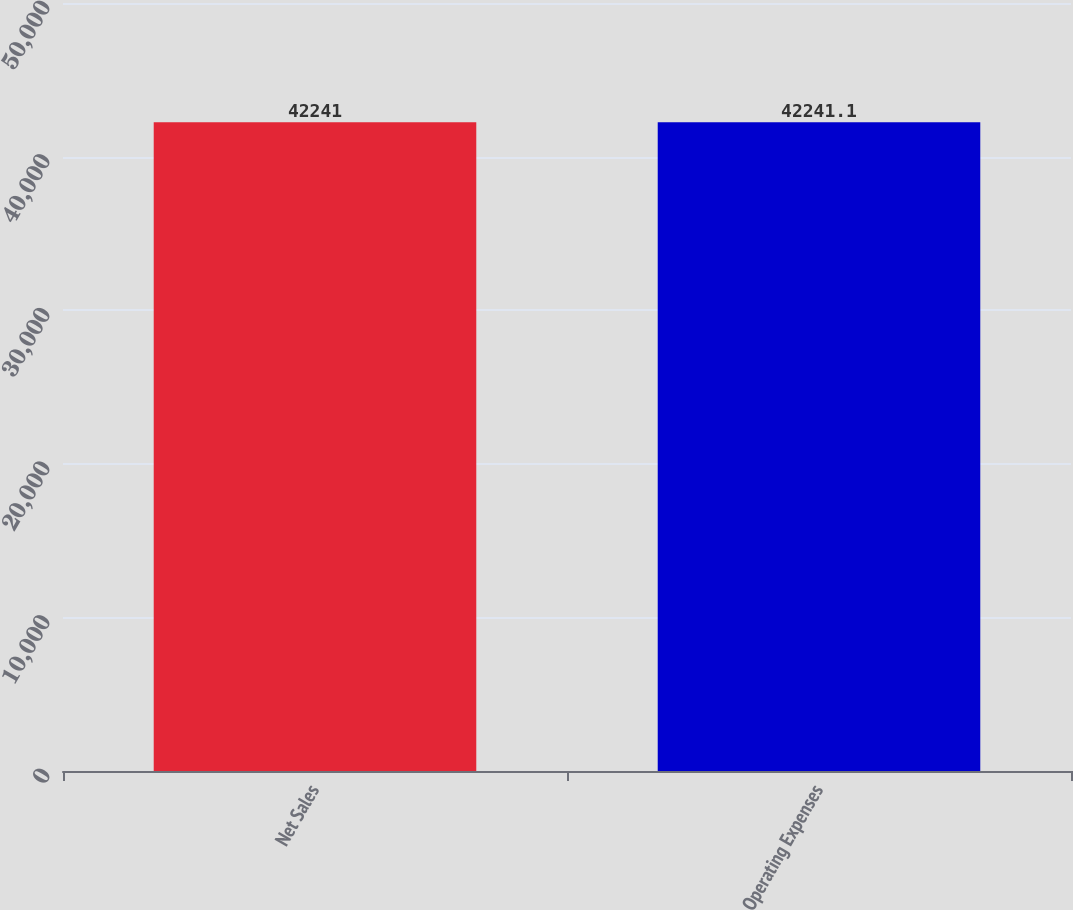<chart> <loc_0><loc_0><loc_500><loc_500><bar_chart><fcel>Net Sales<fcel>Operating Expenses<nl><fcel>42241<fcel>42241.1<nl></chart> 